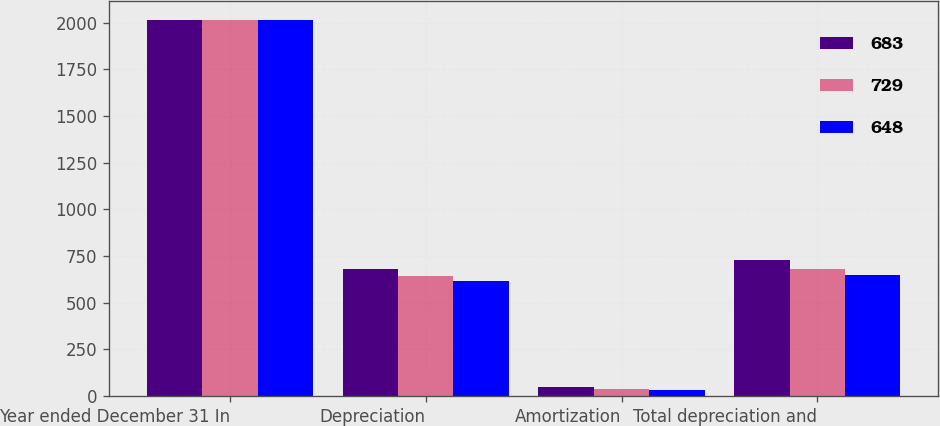<chart> <loc_0><loc_0><loc_500><loc_500><stacked_bar_chart><ecel><fcel>Year ended December 31 In<fcel>Depreciation<fcel>Amortization<fcel>Total depreciation and<nl><fcel>683<fcel>2016<fcel>683<fcel>46<fcel>729<nl><fcel>729<fcel>2015<fcel>643<fcel>40<fcel>683<nl><fcel>648<fcel>2014<fcel>618<fcel>30<fcel>648<nl></chart> 